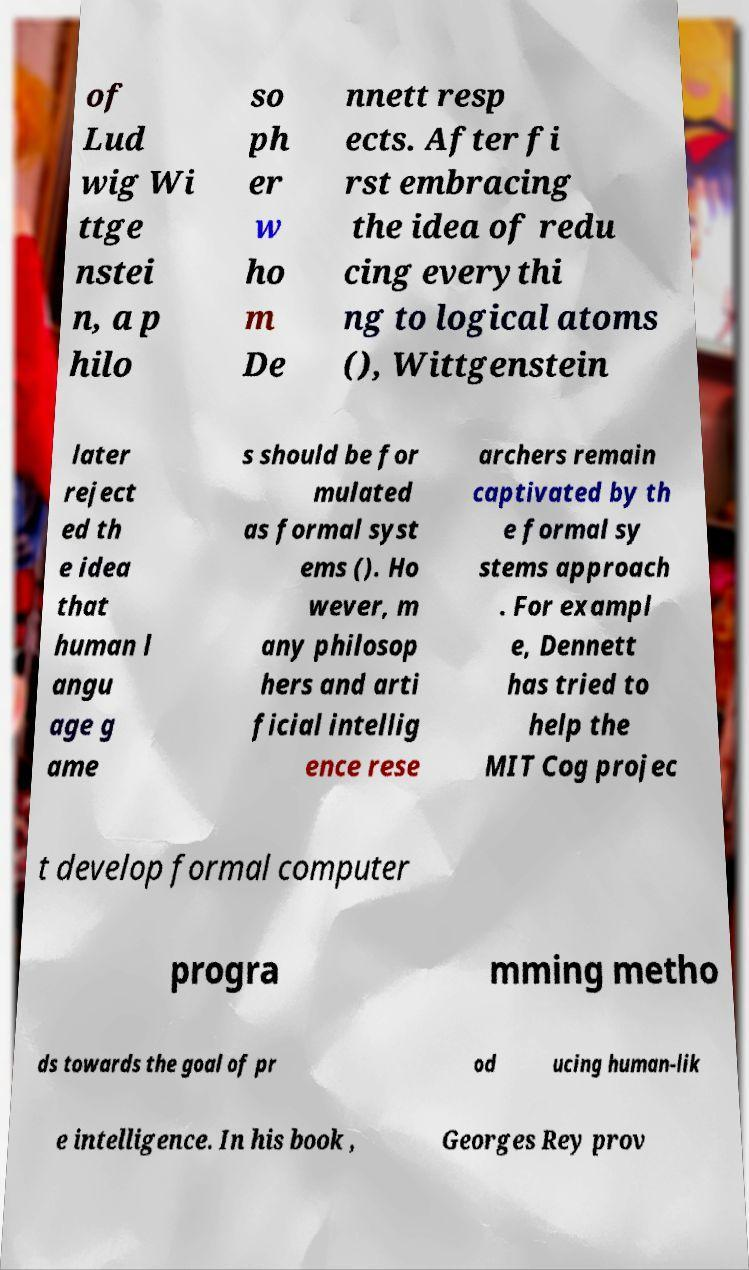For documentation purposes, I need the text within this image transcribed. Could you provide that? of Lud wig Wi ttge nstei n, a p hilo so ph er w ho m De nnett resp ects. After fi rst embracing the idea of redu cing everythi ng to logical atoms (), Wittgenstein later reject ed th e idea that human l angu age g ame s should be for mulated as formal syst ems (). Ho wever, m any philosop hers and arti ficial intellig ence rese archers remain captivated by th e formal sy stems approach . For exampl e, Dennett has tried to help the MIT Cog projec t develop formal computer progra mming metho ds towards the goal of pr od ucing human-lik e intelligence. In his book , Georges Rey prov 